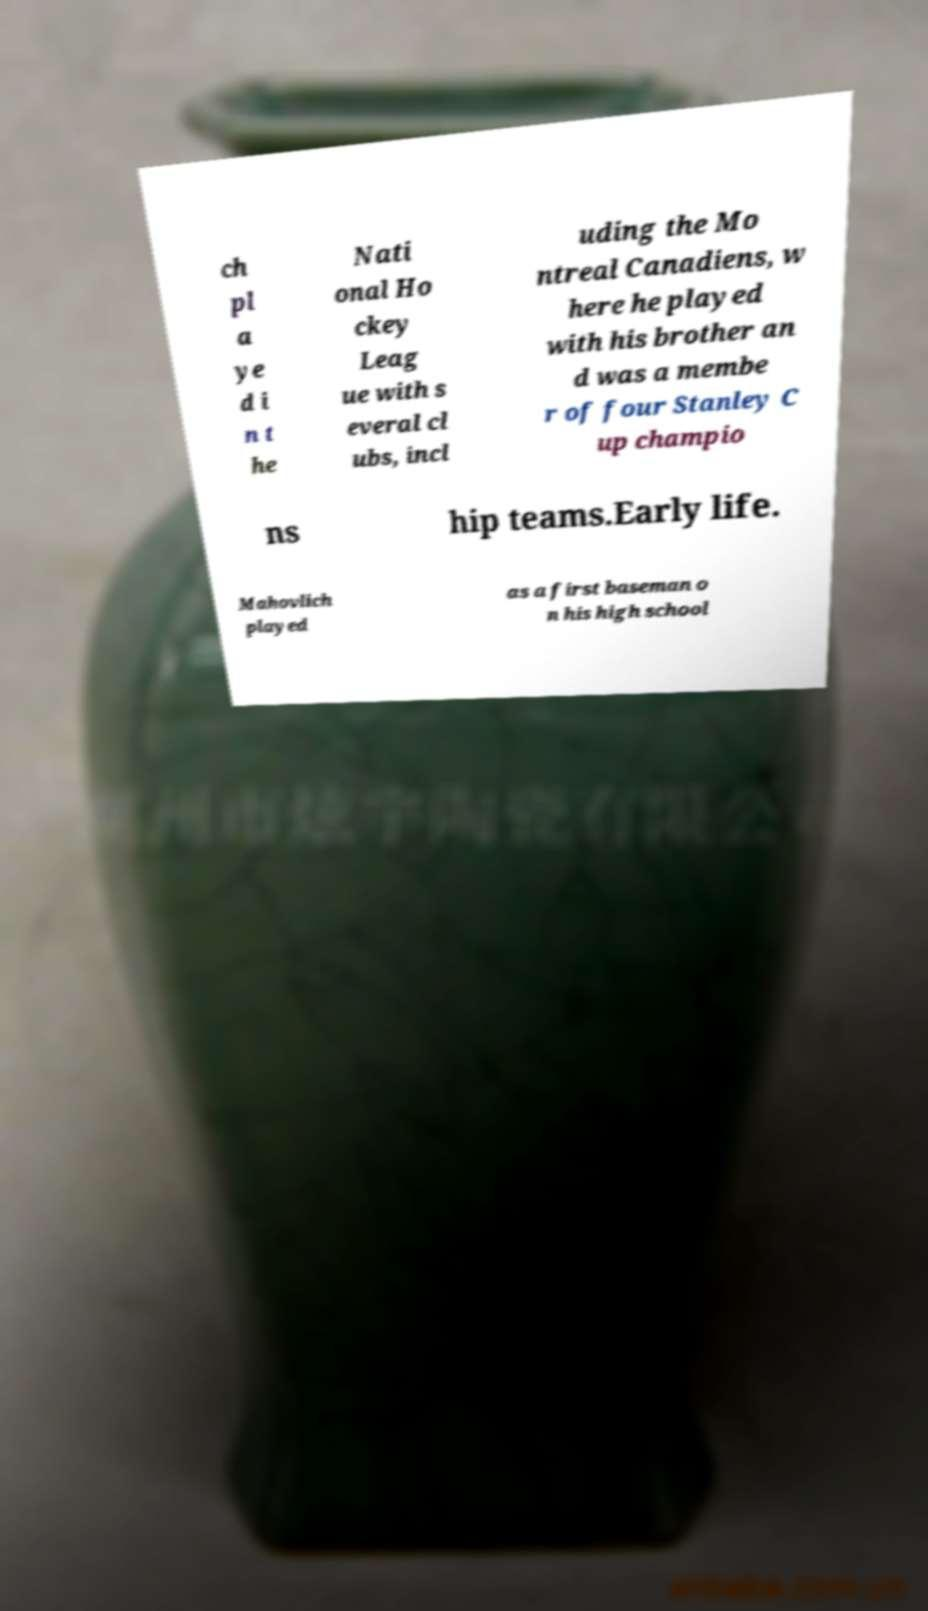Please read and relay the text visible in this image. What does it say? ch pl a ye d i n t he Nati onal Ho ckey Leag ue with s everal cl ubs, incl uding the Mo ntreal Canadiens, w here he played with his brother an d was a membe r of four Stanley C up champio ns hip teams.Early life. Mahovlich played as a first baseman o n his high school 